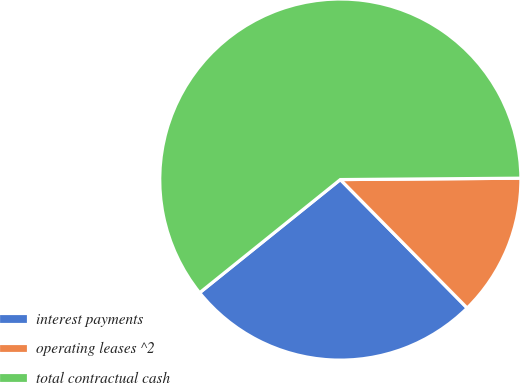Convert chart to OTSL. <chart><loc_0><loc_0><loc_500><loc_500><pie_chart><fcel>interest payments<fcel>operating leases ^2<fcel>total contractual cash<nl><fcel>26.62%<fcel>12.72%<fcel>60.66%<nl></chart> 